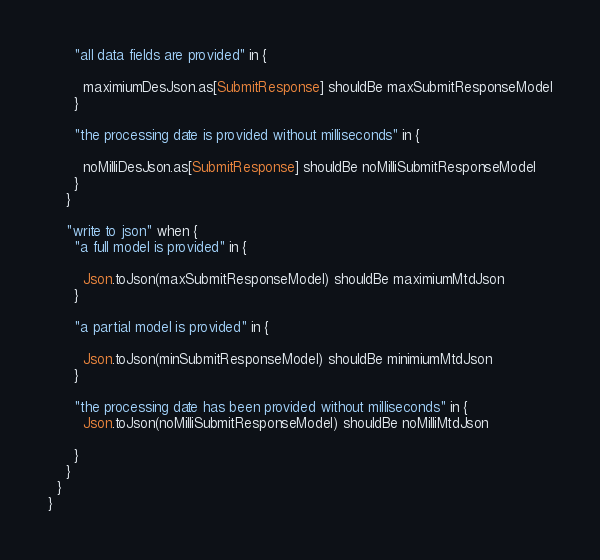<code> <loc_0><loc_0><loc_500><loc_500><_Scala_>
      "all data fields are provided" in {

        maximiumDesJson.as[SubmitResponse] shouldBe maxSubmitResponseModel
      }

      "the processing date is provided without milliseconds" in {

        noMilliDesJson.as[SubmitResponse] shouldBe noMilliSubmitResponseModel
      }
    }

    "write to json" when {
      "a full model is provided" in {

        Json.toJson(maxSubmitResponseModel) shouldBe maximiumMtdJson
      }

      "a partial model is provided" in {

        Json.toJson(minSubmitResponseModel) shouldBe minimiumMtdJson
      }

      "the processing date has been provided without milliseconds" in {
        Json.toJson(noMilliSubmitResponseModel) shouldBe noMilliMtdJson

      }
    }
  }
}
</code> 